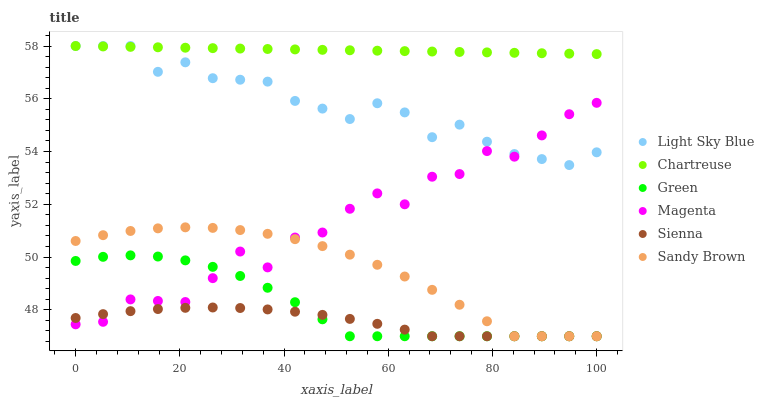Does Sienna have the minimum area under the curve?
Answer yes or no. Yes. Does Chartreuse have the maximum area under the curve?
Answer yes or no. Yes. Does Light Sky Blue have the minimum area under the curve?
Answer yes or no. No. Does Light Sky Blue have the maximum area under the curve?
Answer yes or no. No. Is Chartreuse the smoothest?
Answer yes or no. Yes. Is Magenta the roughest?
Answer yes or no. Yes. Is Light Sky Blue the smoothest?
Answer yes or no. No. Is Light Sky Blue the roughest?
Answer yes or no. No. Does Sienna have the lowest value?
Answer yes or no. Yes. Does Light Sky Blue have the lowest value?
Answer yes or no. No. Does Light Sky Blue have the highest value?
Answer yes or no. Yes. Does Green have the highest value?
Answer yes or no. No. Is Sandy Brown less than Chartreuse?
Answer yes or no. Yes. Is Chartreuse greater than Sienna?
Answer yes or no. Yes. Does Green intersect Magenta?
Answer yes or no. Yes. Is Green less than Magenta?
Answer yes or no. No. Is Green greater than Magenta?
Answer yes or no. No. Does Sandy Brown intersect Chartreuse?
Answer yes or no. No. 